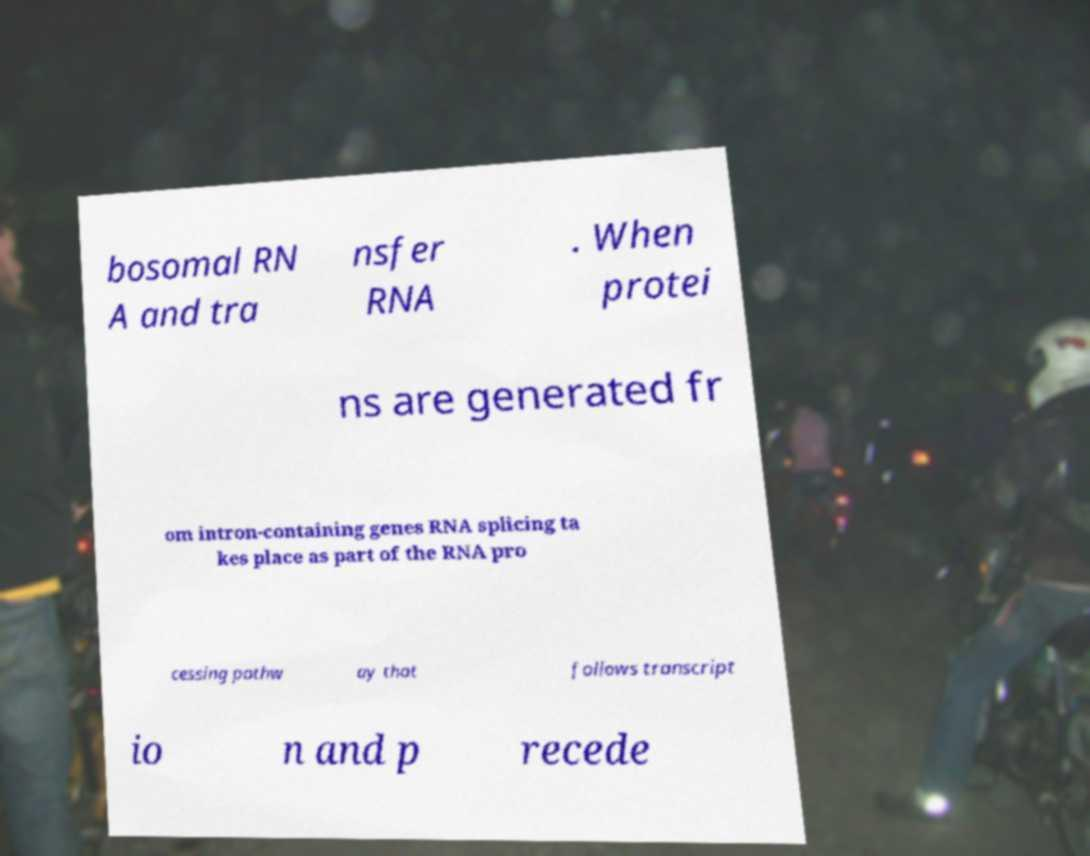What messages or text are displayed in this image? I need them in a readable, typed format. bosomal RN A and tra nsfer RNA . When protei ns are generated fr om intron-containing genes RNA splicing ta kes place as part of the RNA pro cessing pathw ay that follows transcript io n and p recede 